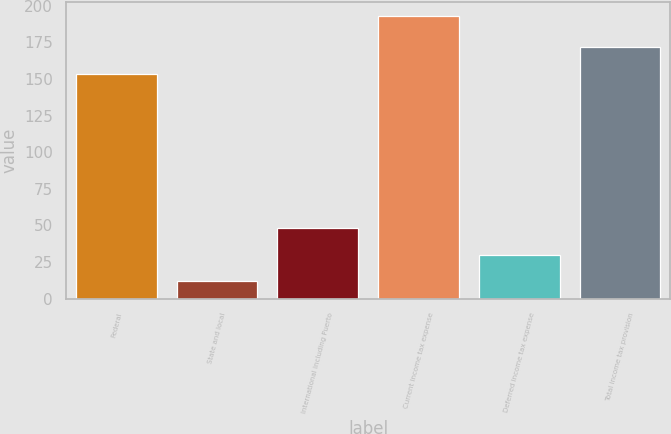Convert chart to OTSL. <chart><loc_0><loc_0><loc_500><loc_500><bar_chart><fcel>Federal<fcel>State and local<fcel>International including Puerto<fcel>Current income tax expense<fcel>Deferred income tax expense<fcel>Total income tax provision<nl><fcel>153.4<fcel>12.1<fcel>48.26<fcel>192.9<fcel>30.18<fcel>171.48<nl></chart> 